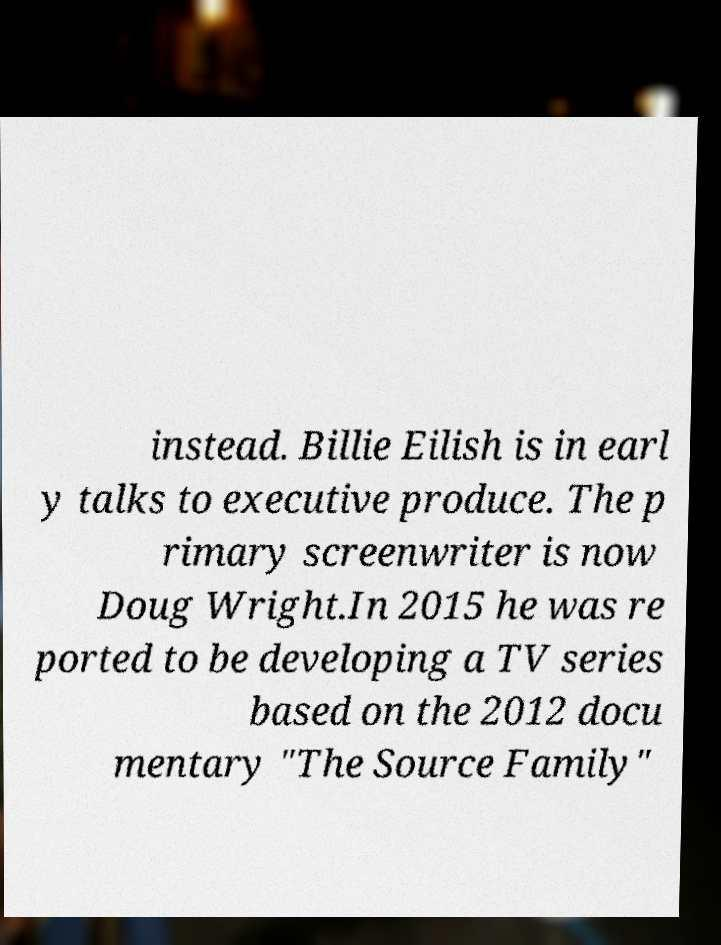For documentation purposes, I need the text within this image transcribed. Could you provide that? instead. Billie Eilish is in earl y talks to executive produce. The p rimary screenwriter is now Doug Wright.In 2015 he was re ported to be developing a TV series based on the 2012 docu mentary "The Source Family" 